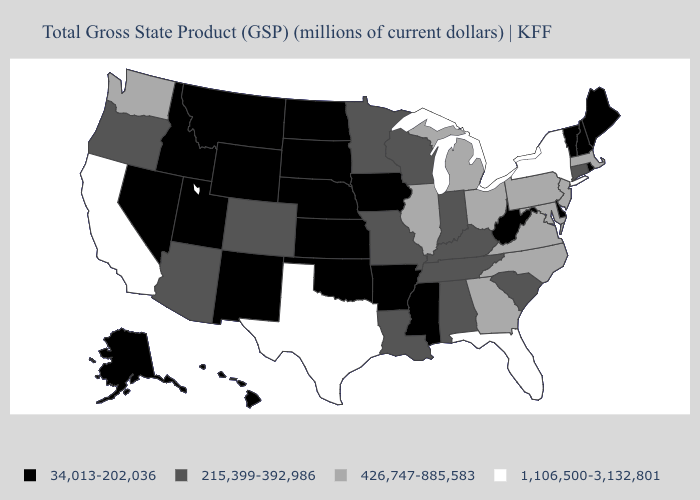Name the states that have a value in the range 1,106,500-3,132,801?
Concise answer only. California, Florida, New York, Texas. Which states hav the highest value in the South?
Keep it brief. Florida, Texas. What is the lowest value in the MidWest?
Write a very short answer. 34,013-202,036. Among the states that border Oregon , which have the highest value?
Write a very short answer. California. Is the legend a continuous bar?
Keep it brief. No. What is the value of Mississippi?
Write a very short answer. 34,013-202,036. What is the lowest value in the USA?
Quick response, please. 34,013-202,036. Among the states that border Pennsylvania , which have the lowest value?
Short answer required. Delaware, West Virginia. Which states have the highest value in the USA?
Give a very brief answer. California, Florida, New York, Texas. Does New Hampshire have a lower value than Michigan?
Short answer required. Yes. What is the value of New Hampshire?
Keep it brief. 34,013-202,036. Among the states that border Minnesota , does North Dakota have the lowest value?
Answer briefly. Yes. What is the lowest value in the Northeast?
Concise answer only. 34,013-202,036. Which states have the lowest value in the USA?
Quick response, please. Alaska, Arkansas, Delaware, Hawaii, Idaho, Iowa, Kansas, Maine, Mississippi, Montana, Nebraska, Nevada, New Hampshire, New Mexico, North Dakota, Oklahoma, Rhode Island, South Dakota, Utah, Vermont, West Virginia, Wyoming. What is the highest value in the MidWest ?
Quick response, please. 426,747-885,583. 